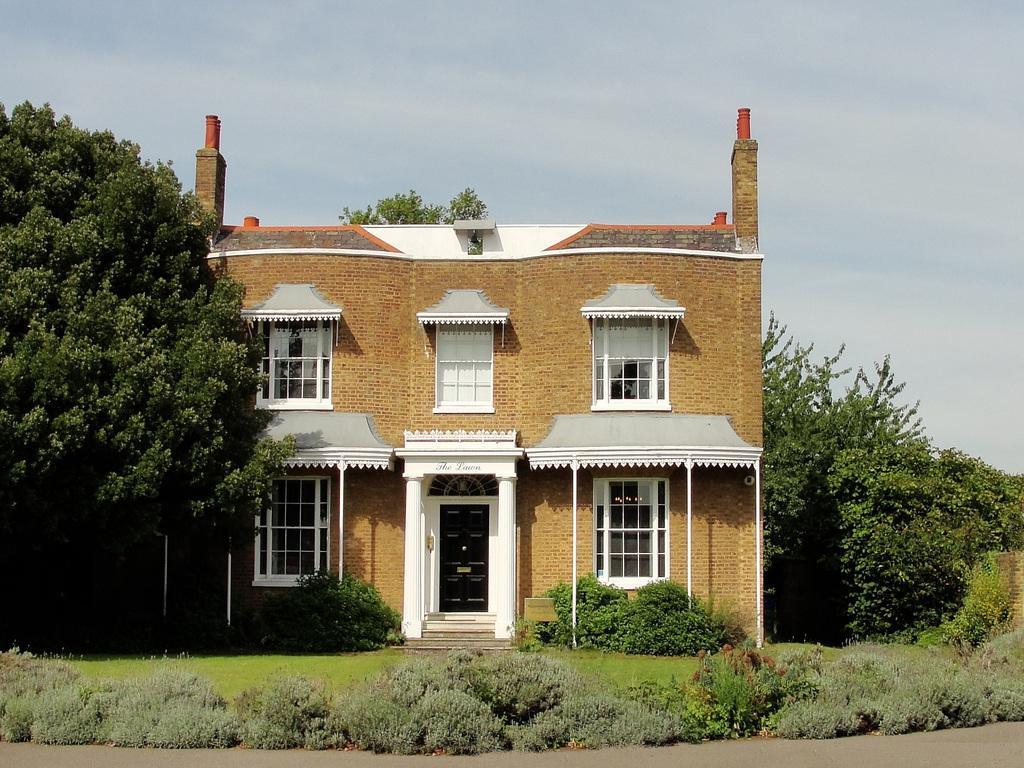Please provide a concise description of this image. In this image there is the sky truncated towards the top of the image, there are trees truncated towards the right of the image, there are trees truncated towards the left of the image, there is a building, there are windows, there is the door, there is text on the building, there are pillars, there are plants truncated, there is the grass, there is the road truncated towards the bottom of the image. 